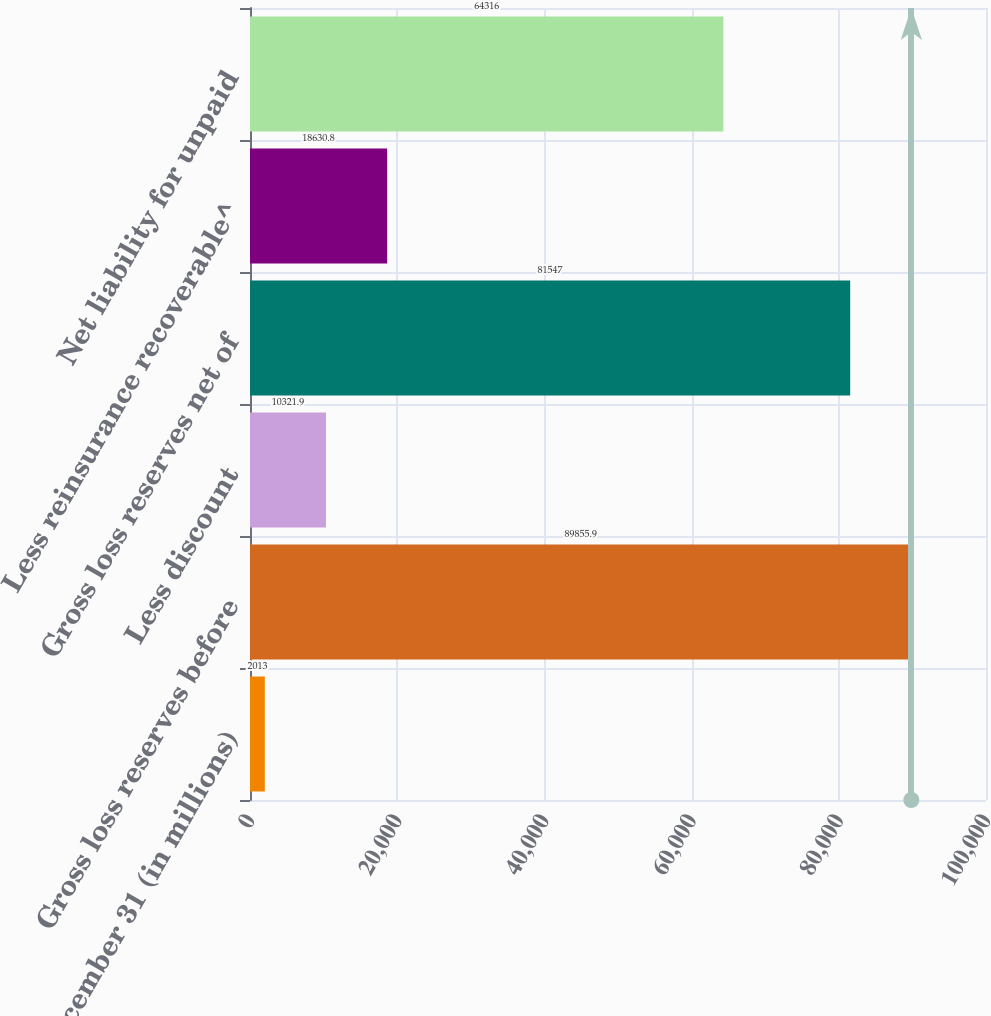Convert chart. <chart><loc_0><loc_0><loc_500><loc_500><bar_chart><fcel>December 31 (in millions)<fcel>Gross loss reserves before<fcel>Less discount<fcel>Gross loss reserves net of<fcel>Less reinsurance recoverable^<fcel>Net liability for unpaid<nl><fcel>2013<fcel>89855.9<fcel>10321.9<fcel>81547<fcel>18630.8<fcel>64316<nl></chart> 